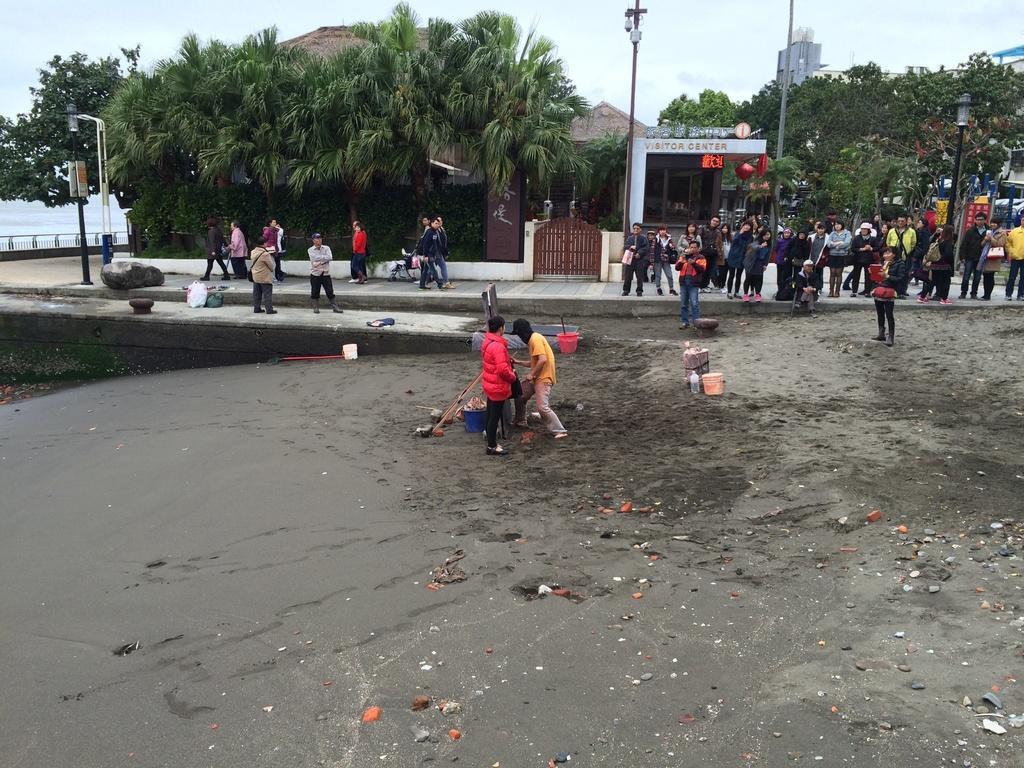Please provide a concise description of this image. In this image there is a ground in the bottom of this image and there are two persons are standing in middle of this image. There are some other persons are standing on the right side of this image and left side of this image as well. There are some trees in the background. There are some buildings as we can see on the top right corner of this image. There is a sky on the top of this image. 